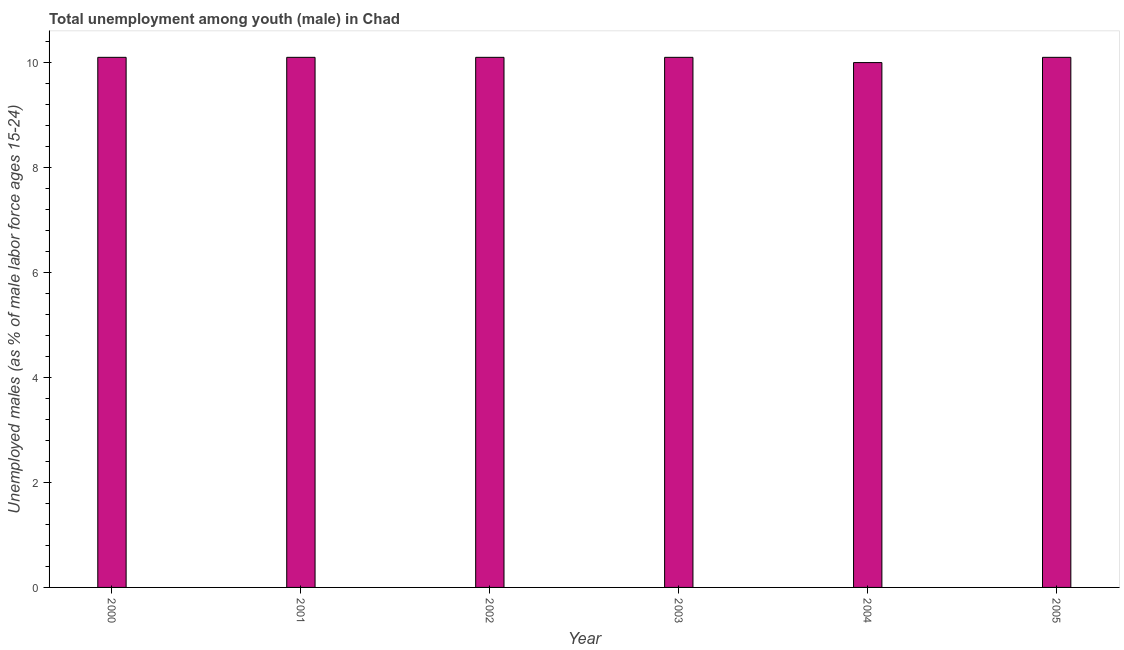What is the title of the graph?
Your response must be concise. Total unemployment among youth (male) in Chad. What is the label or title of the Y-axis?
Your answer should be very brief. Unemployed males (as % of male labor force ages 15-24). What is the unemployed male youth population in 2004?
Keep it short and to the point. 10. Across all years, what is the maximum unemployed male youth population?
Ensure brevity in your answer.  10.1. What is the sum of the unemployed male youth population?
Offer a very short reply. 60.5. What is the difference between the unemployed male youth population in 2002 and 2003?
Give a very brief answer. 0. What is the average unemployed male youth population per year?
Provide a short and direct response. 10.08. What is the median unemployed male youth population?
Make the answer very short. 10.1. Do a majority of the years between 2002 and 2005 (inclusive) have unemployed male youth population greater than 8 %?
Your answer should be very brief. Yes. Is the sum of the unemployed male youth population in 2000 and 2005 greater than the maximum unemployed male youth population across all years?
Make the answer very short. Yes. How many years are there in the graph?
Your response must be concise. 6. What is the difference between two consecutive major ticks on the Y-axis?
Your answer should be very brief. 2. What is the Unemployed males (as % of male labor force ages 15-24) of 2000?
Provide a short and direct response. 10.1. What is the Unemployed males (as % of male labor force ages 15-24) of 2001?
Your answer should be compact. 10.1. What is the Unemployed males (as % of male labor force ages 15-24) in 2002?
Offer a terse response. 10.1. What is the Unemployed males (as % of male labor force ages 15-24) of 2003?
Keep it short and to the point. 10.1. What is the Unemployed males (as % of male labor force ages 15-24) of 2005?
Your answer should be compact. 10.1. What is the difference between the Unemployed males (as % of male labor force ages 15-24) in 2000 and 2002?
Keep it short and to the point. 0. What is the difference between the Unemployed males (as % of male labor force ages 15-24) in 2000 and 2004?
Provide a succinct answer. 0.1. What is the difference between the Unemployed males (as % of male labor force ages 15-24) in 2001 and 2002?
Your answer should be very brief. 0. What is the difference between the Unemployed males (as % of male labor force ages 15-24) in 2001 and 2003?
Your answer should be compact. 0. What is the difference between the Unemployed males (as % of male labor force ages 15-24) in 2001 and 2004?
Provide a short and direct response. 0.1. What is the difference between the Unemployed males (as % of male labor force ages 15-24) in 2001 and 2005?
Make the answer very short. 0. What is the difference between the Unemployed males (as % of male labor force ages 15-24) in 2003 and 2004?
Your response must be concise. 0.1. What is the difference between the Unemployed males (as % of male labor force ages 15-24) in 2004 and 2005?
Your answer should be very brief. -0.1. What is the ratio of the Unemployed males (as % of male labor force ages 15-24) in 2000 to that in 2001?
Give a very brief answer. 1. What is the ratio of the Unemployed males (as % of male labor force ages 15-24) in 2000 to that in 2002?
Ensure brevity in your answer.  1. What is the ratio of the Unemployed males (as % of male labor force ages 15-24) in 2000 to that in 2003?
Your answer should be compact. 1. What is the ratio of the Unemployed males (as % of male labor force ages 15-24) in 2000 to that in 2004?
Your answer should be very brief. 1.01. What is the ratio of the Unemployed males (as % of male labor force ages 15-24) in 2000 to that in 2005?
Make the answer very short. 1. What is the ratio of the Unemployed males (as % of male labor force ages 15-24) in 2001 to that in 2002?
Give a very brief answer. 1. What is the ratio of the Unemployed males (as % of male labor force ages 15-24) in 2001 to that in 2003?
Your answer should be compact. 1. What is the ratio of the Unemployed males (as % of male labor force ages 15-24) in 2001 to that in 2004?
Your answer should be very brief. 1.01. What is the ratio of the Unemployed males (as % of male labor force ages 15-24) in 2001 to that in 2005?
Ensure brevity in your answer.  1. What is the ratio of the Unemployed males (as % of male labor force ages 15-24) in 2002 to that in 2003?
Give a very brief answer. 1. What is the ratio of the Unemployed males (as % of male labor force ages 15-24) in 2002 to that in 2004?
Your answer should be very brief. 1.01. What is the ratio of the Unemployed males (as % of male labor force ages 15-24) in 2002 to that in 2005?
Your answer should be compact. 1. 